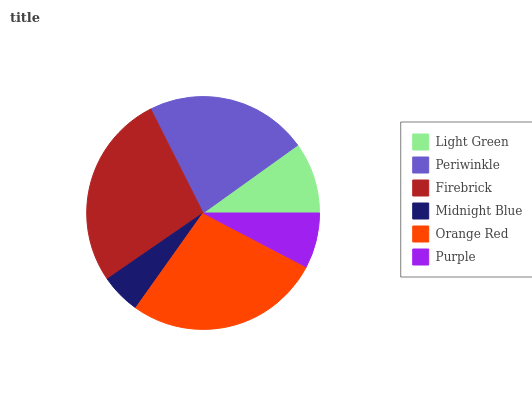Is Midnight Blue the minimum?
Answer yes or no. Yes. Is Firebrick the maximum?
Answer yes or no. Yes. Is Periwinkle the minimum?
Answer yes or no. No. Is Periwinkle the maximum?
Answer yes or no. No. Is Periwinkle greater than Light Green?
Answer yes or no. Yes. Is Light Green less than Periwinkle?
Answer yes or no. Yes. Is Light Green greater than Periwinkle?
Answer yes or no. No. Is Periwinkle less than Light Green?
Answer yes or no. No. Is Periwinkle the high median?
Answer yes or no. Yes. Is Light Green the low median?
Answer yes or no. Yes. Is Light Green the high median?
Answer yes or no. No. Is Midnight Blue the low median?
Answer yes or no. No. 